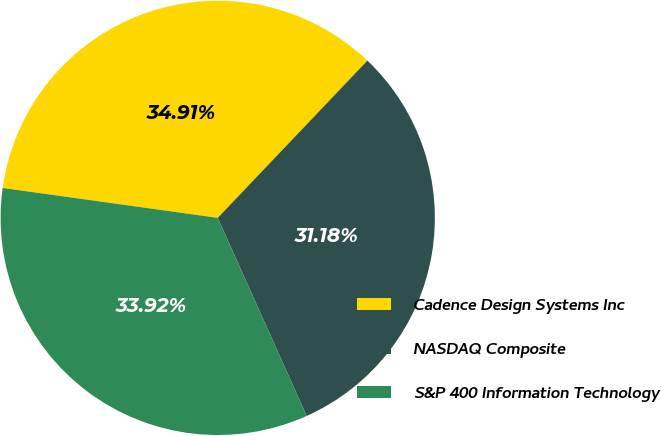Convert chart to OTSL. <chart><loc_0><loc_0><loc_500><loc_500><pie_chart><fcel>Cadence Design Systems Inc<fcel>NASDAQ Composite<fcel>S&P 400 Information Technology<nl><fcel>34.91%<fcel>31.18%<fcel>33.92%<nl></chart> 